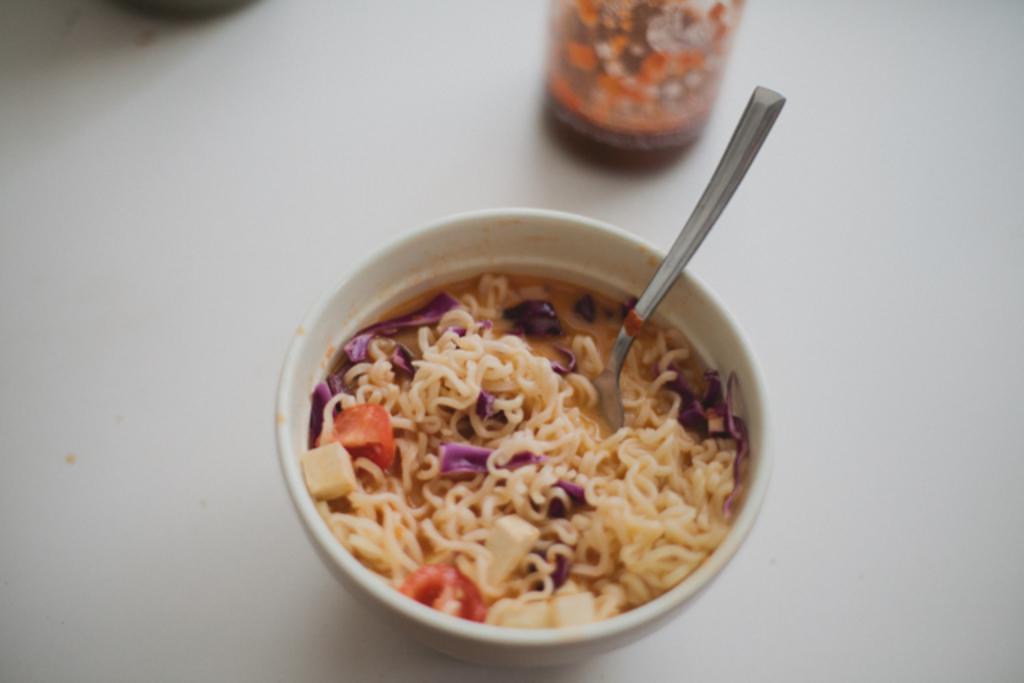Could you give a brief overview of what you see in this image? In this image I see the white surface on which there is a white bowl on which there are noodles and I see few ingredients which are of purple, cream and red in color and I see a spoon in it and I see a thing over here. 